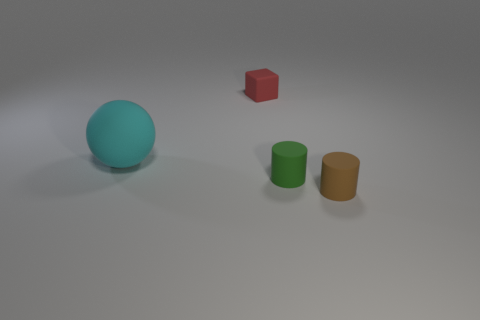Add 2 cyan things. How many objects exist? 6 Subtract all spheres. How many objects are left? 3 Add 2 tiny rubber blocks. How many tiny rubber blocks are left? 3 Add 3 tiny gray matte cubes. How many tiny gray matte cubes exist? 3 Subtract 0 yellow spheres. How many objects are left? 4 Subtract all large gray rubber blocks. Subtract all big rubber objects. How many objects are left? 3 